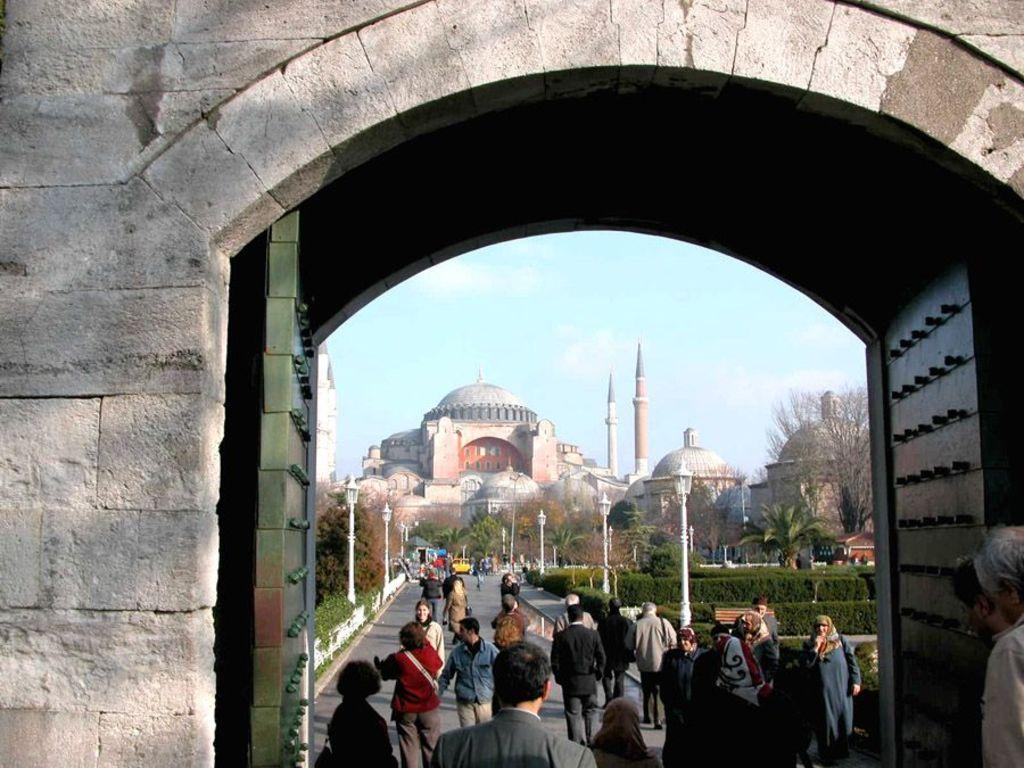What are the people in the image doing? There are many people walking on the path in the image. What can be seen on either side of the path? Plants and trees are present on either side of the path. What is visible in the background of the image? There is a palace in the background of the image. What is visible in the sky in the image? The sky is visible in the image, and clouds are present in the sky. What language are the people speaking in the image? There is no information about the language spoken by the people in the image. How many baseballs can be seen on the path in the image? There are no baseballs present in the image; it features people walking on a path surrounded by plants, trees, and a palace in the background. 